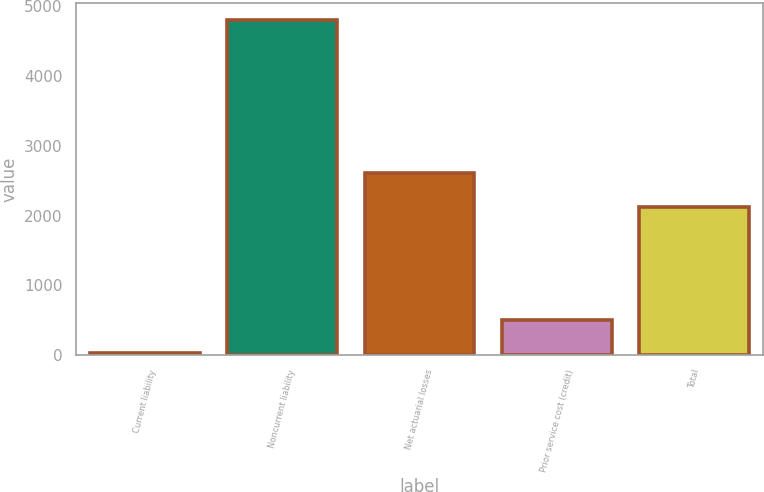Convert chart. <chart><loc_0><loc_0><loc_500><loc_500><bar_chart><fcel>Current liability<fcel>Noncurrent liability<fcel>Net actuarial losses<fcel>Prior service cost (credit)<fcel>Total<nl><fcel>27<fcel>4803<fcel>2603.6<fcel>504.6<fcel>2126<nl></chart> 